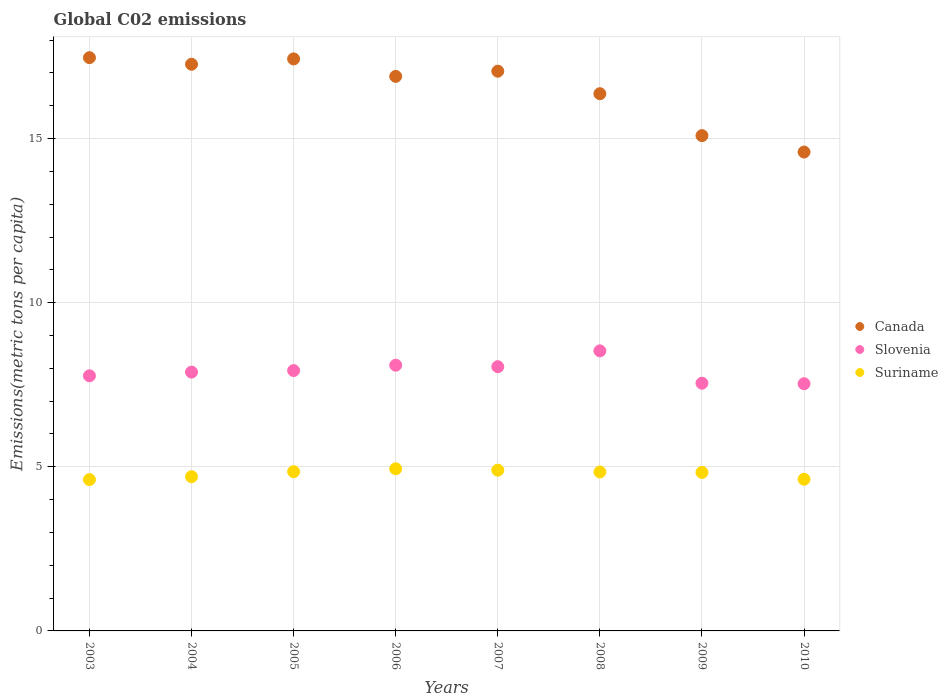Is the number of dotlines equal to the number of legend labels?
Your response must be concise. Yes. What is the amount of CO2 emitted in in Slovenia in 2003?
Your answer should be compact. 7.77. Across all years, what is the maximum amount of CO2 emitted in in Canada?
Give a very brief answer. 17.46. Across all years, what is the minimum amount of CO2 emitted in in Slovenia?
Provide a short and direct response. 7.53. What is the total amount of CO2 emitted in in Canada in the graph?
Ensure brevity in your answer.  132.14. What is the difference between the amount of CO2 emitted in in Suriname in 2004 and that in 2007?
Your answer should be very brief. -0.2. What is the difference between the amount of CO2 emitted in in Suriname in 2004 and the amount of CO2 emitted in in Canada in 2008?
Offer a very short reply. -11.67. What is the average amount of CO2 emitted in in Slovenia per year?
Your answer should be compact. 7.92. In the year 2004, what is the difference between the amount of CO2 emitted in in Suriname and amount of CO2 emitted in in Canada?
Your response must be concise. -12.56. What is the ratio of the amount of CO2 emitted in in Canada in 2005 to that in 2006?
Provide a succinct answer. 1.03. Is the difference between the amount of CO2 emitted in in Suriname in 2005 and 2007 greater than the difference between the amount of CO2 emitted in in Canada in 2005 and 2007?
Ensure brevity in your answer.  No. What is the difference between the highest and the second highest amount of CO2 emitted in in Canada?
Provide a succinct answer. 0.04. What is the difference between the highest and the lowest amount of CO2 emitted in in Slovenia?
Provide a succinct answer. 1. Does the amount of CO2 emitted in in Canada monotonically increase over the years?
Your answer should be compact. No. How many dotlines are there?
Provide a succinct answer. 3. What is the difference between two consecutive major ticks on the Y-axis?
Provide a short and direct response. 5. Are the values on the major ticks of Y-axis written in scientific E-notation?
Ensure brevity in your answer.  No. Does the graph contain grids?
Give a very brief answer. Yes. How are the legend labels stacked?
Offer a terse response. Vertical. What is the title of the graph?
Your answer should be compact. Global C02 emissions. What is the label or title of the X-axis?
Make the answer very short. Years. What is the label or title of the Y-axis?
Your answer should be very brief. Emissions(metric tons per capita). What is the Emissions(metric tons per capita) in Canada in 2003?
Your answer should be very brief. 17.46. What is the Emissions(metric tons per capita) of Slovenia in 2003?
Your response must be concise. 7.77. What is the Emissions(metric tons per capita) in Suriname in 2003?
Make the answer very short. 4.61. What is the Emissions(metric tons per capita) in Canada in 2004?
Give a very brief answer. 17.26. What is the Emissions(metric tons per capita) in Slovenia in 2004?
Your answer should be very brief. 7.88. What is the Emissions(metric tons per capita) of Suriname in 2004?
Give a very brief answer. 4.7. What is the Emissions(metric tons per capita) of Canada in 2005?
Give a very brief answer. 17.43. What is the Emissions(metric tons per capita) in Slovenia in 2005?
Offer a terse response. 7.93. What is the Emissions(metric tons per capita) of Suriname in 2005?
Ensure brevity in your answer.  4.85. What is the Emissions(metric tons per capita) of Canada in 2006?
Offer a very short reply. 16.89. What is the Emissions(metric tons per capita) of Slovenia in 2006?
Make the answer very short. 8.09. What is the Emissions(metric tons per capita) in Suriname in 2006?
Offer a terse response. 4.94. What is the Emissions(metric tons per capita) of Canada in 2007?
Your response must be concise. 17.05. What is the Emissions(metric tons per capita) in Slovenia in 2007?
Your answer should be very brief. 8.05. What is the Emissions(metric tons per capita) in Suriname in 2007?
Provide a succinct answer. 4.9. What is the Emissions(metric tons per capita) of Canada in 2008?
Give a very brief answer. 16.37. What is the Emissions(metric tons per capita) of Slovenia in 2008?
Provide a short and direct response. 8.53. What is the Emissions(metric tons per capita) in Suriname in 2008?
Ensure brevity in your answer.  4.84. What is the Emissions(metric tons per capita) in Canada in 2009?
Provide a short and direct response. 15.09. What is the Emissions(metric tons per capita) of Slovenia in 2009?
Give a very brief answer. 7.55. What is the Emissions(metric tons per capita) in Suriname in 2009?
Make the answer very short. 4.83. What is the Emissions(metric tons per capita) in Canada in 2010?
Keep it short and to the point. 14.59. What is the Emissions(metric tons per capita) of Slovenia in 2010?
Provide a succinct answer. 7.53. What is the Emissions(metric tons per capita) in Suriname in 2010?
Keep it short and to the point. 4.62. Across all years, what is the maximum Emissions(metric tons per capita) of Canada?
Offer a terse response. 17.46. Across all years, what is the maximum Emissions(metric tons per capita) in Slovenia?
Give a very brief answer. 8.53. Across all years, what is the maximum Emissions(metric tons per capita) of Suriname?
Your answer should be very brief. 4.94. Across all years, what is the minimum Emissions(metric tons per capita) in Canada?
Provide a succinct answer. 14.59. Across all years, what is the minimum Emissions(metric tons per capita) in Slovenia?
Keep it short and to the point. 7.53. Across all years, what is the minimum Emissions(metric tons per capita) in Suriname?
Give a very brief answer. 4.61. What is the total Emissions(metric tons per capita) of Canada in the graph?
Your answer should be very brief. 132.14. What is the total Emissions(metric tons per capita) in Slovenia in the graph?
Your answer should be very brief. 63.34. What is the total Emissions(metric tons per capita) in Suriname in the graph?
Your answer should be compact. 38.29. What is the difference between the Emissions(metric tons per capita) of Canada in 2003 and that in 2004?
Your answer should be very brief. 0.2. What is the difference between the Emissions(metric tons per capita) of Slovenia in 2003 and that in 2004?
Keep it short and to the point. -0.11. What is the difference between the Emissions(metric tons per capita) of Suriname in 2003 and that in 2004?
Your answer should be very brief. -0.09. What is the difference between the Emissions(metric tons per capita) of Canada in 2003 and that in 2005?
Provide a succinct answer. 0.04. What is the difference between the Emissions(metric tons per capita) in Slovenia in 2003 and that in 2005?
Ensure brevity in your answer.  -0.16. What is the difference between the Emissions(metric tons per capita) of Suriname in 2003 and that in 2005?
Provide a short and direct response. -0.24. What is the difference between the Emissions(metric tons per capita) in Canada in 2003 and that in 2006?
Keep it short and to the point. 0.57. What is the difference between the Emissions(metric tons per capita) of Slovenia in 2003 and that in 2006?
Offer a very short reply. -0.32. What is the difference between the Emissions(metric tons per capita) of Suriname in 2003 and that in 2006?
Provide a short and direct response. -0.33. What is the difference between the Emissions(metric tons per capita) of Canada in 2003 and that in 2007?
Your answer should be compact. 0.41. What is the difference between the Emissions(metric tons per capita) of Slovenia in 2003 and that in 2007?
Offer a terse response. -0.28. What is the difference between the Emissions(metric tons per capita) of Suriname in 2003 and that in 2007?
Offer a terse response. -0.29. What is the difference between the Emissions(metric tons per capita) in Canada in 2003 and that in 2008?
Provide a short and direct response. 1.1. What is the difference between the Emissions(metric tons per capita) of Slovenia in 2003 and that in 2008?
Your response must be concise. -0.76. What is the difference between the Emissions(metric tons per capita) in Suriname in 2003 and that in 2008?
Offer a very short reply. -0.23. What is the difference between the Emissions(metric tons per capita) in Canada in 2003 and that in 2009?
Your response must be concise. 2.37. What is the difference between the Emissions(metric tons per capita) of Slovenia in 2003 and that in 2009?
Ensure brevity in your answer.  0.23. What is the difference between the Emissions(metric tons per capita) of Suriname in 2003 and that in 2009?
Keep it short and to the point. -0.22. What is the difference between the Emissions(metric tons per capita) of Canada in 2003 and that in 2010?
Keep it short and to the point. 2.87. What is the difference between the Emissions(metric tons per capita) of Slovenia in 2003 and that in 2010?
Your response must be concise. 0.24. What is the difference between the Emissions(metric tons per capita) in Suriname in 2003 and that in 2010?
Ensure brevity in your answer.  -0.01. What is the difference between the Emissions(metric tons per capita) in Canada in 2004 and that in 2005?
Your answer should be compact. -0.16. What is the difference between the Emissions(metric tons per capita) in Slovenia in 2004 and that in 2005?
Provide a short and direct response. -0.05. What is the difference between the Emissions(metric tons per capita) of Suriname in 2004 and that in 2005?
Your answer should be compact. -0.15. What is the difference between the Emissions(metric tons per capita) of Canada in 2004 and that in 2006?
Give a very brief answer. 0.37. What is the difference between the Emissions(metric tons per capita) of Slovenia in 2004 and that in 2006?
Offer a terse response. -0.21. What is the difference between the Emissions(metric tons per capita) in Suriname in 2004 and that in 2006?
Your response must be concise. -0.24. What is the difference between the Emissions(metric tons per capita) of Canada in 2004 and that in 2007?
Ensure brevity in your answer.  0.21. What is the difference between the Emissions(metric tons per capita) in Slovenia in 2004 and that in 2007?
Keep it short and to the point. -0.16. What is the difference between the Emissions(metric tons per capita) in Suriname in 2004 and that in 2007?
Your response must be concise. -0.2. What is the difference between the Emissions(metric tons per capita) of Canada in 2004 and that in 2008?
Your answer should be very brief. 0.9. What is the difference between the Emissions(metric tons per capita) in Slovenia in 2004 and that in 2008?
Your answer should be compact. -0.65. What is the difference between the Emissions(metric tons per capita) of Suriname in 2004 and that in 2008?
Your answer should be compact. -0.14. What is the difference between the Emissions(metric tons per capita) in Canada in 2004 and that in 2009?
Make the answer very short. 2.17. What is the difference between the Emissions(metric tons per capita) of Slovenia in 2004 and that in 2009?
Ensure brevity in your answer.  0.34. What is the difference between the Emissions(metric tons per capita) in Suriname in 2004 and that in 2009?
Offer a very short reply. -0.13. What is the difference between the Emissions(metric tons per capita) of Canada in 2004 and that in 2010?
Provide a succinct answer. 2.67. What is the difference between the Emissions(metric tons per capita) in Slovenia in 2004 and that in 2010?
Ensure brevity in your answer.  0.35. What is the difference between the Emissions(metric tons per capita) in Suriname in 2004 and that in 2010?
Provide a succinct answer. 0.08. What is the difference between the Emissions(metric tons per capita) in Canada in 2005 and that in 2006?
Keep it short and to the point. 0.53. What is the difference between the Emissions(metric tons per capita) of Slovenia in 2005 and that in 2006?
Make the answer very short. -0.16. What is the difference between the Emissions(metric tons per capita) of Suriname in 2005 and that in 2006?
Your answer should be compact. -0.09. What is the difference between the Emissions(metric tons per capita) of Canada in 2005 and that in 2007?
Make the answer very short. 0.37. What is the difference between the Emissions(metric tons per capita) of Slovenia in 2005 and that in 2007?
Offer a very short reply. -0.12. What is the difference between the Emissions(metric tons per capita) in Suriname in 2005 and that in 2007?
Keep it short and to the point. -0.04. What is the difference between the Emissions(metric tons per capita) in Canada in 2005 and that in 2008?
Keep it short and to the point. 1.06. What is the difference between the Emissions(metric tons per capita) in Slovenia in 2005 and that in 2008?
Your response must be concise. -0.6. What is the difference between the Emissions(metric tons per capita) in Suriname in 2005 and that in 2008?
Provide a succinct answer. 0.01. What is the difference between the Emissions(metric tons per capita) of Canada in 2005 and that in 2009?
Provide a short and direct response. 2.34. What is the difference between the Emissions(metric tons per capita) in Slovenia in 2005 and that in 2009?
Your answer should be compact. 0.38. What is the difference between the Emissions(metric tons per capita) of Suriname in 2005 and that in 2009?
Make the answer very short. 0.02. What is the difference between the Emissions(metric tons per capita) in Canada in 2005 and that in 2010?
Offer a terse response. 2.84. What is the difference between the Emissions(metric tons per capita) in Slovenia in 2005 and that in 2010?
Keep it short and to the point. 0.4. What is the difference between the Emissions(metric tons per capita) in Suriname in 2005 and that in 2010?
Provide a short and direct response. 0.23. What is the difference between the Emissions(metric tons per capita) of Canada in 2006 and that in 2007?
Offer a terse response. -0.16. What is the difference between the Emissions(metric tons per capita) of Slovenia in 2006 and that in 2007?
Your answer should be compact. 0.05. What is the difference between the Emissions(metric tons per capita) of Suriname in 2006 and that in 2007?
Your answer should be very brief. 0.04. What is the difference between the Emissions(metric tons per capita) of Canada in 2006 and that in 2008?
Give a very brief answer. 0.53. What is the difference between the Emissions(metric tons per capita) of Slovenia in 2006 and that in 2008?
Keep it short and to the point. -0.44. What is the difference between the Emissions(metric tons per capita) in Suriname in 2006 and that in 2008?
Your answer should be compact. 0.1. What is the difference between the Emissions(metric tons per capita) in Canada in 2006 and that in 2009?
Keep it short and to the point. 1.8. What is the difference between the Emissions(metric tons per capita) of Slovenia in 2006 and that in 2009?
Your answer should be very brief. 0.55. What is the difference between the Emissions(metric tons per capita) in Suriname in 2006 and that in 2009?
Your response must be concise. 0.11. What is the difference between the Emissions(metric tons per capita) of Canada in 2006 and that in 2010?
Offer a very short reply. 2.3. What is the difference between the Emissions(metric tons per capita) in Slovenia in 2006 and that in 2010?
Provide a short and direct response. 0.56. What is the difference between the Emissions(metric tons per capita) of Suriname in 2006 and that in 2010?
Offer a very short reply. 0.32. What is the difference between the Emissions(metric tons per capita) of Canada in 2007 and that in 2008?
Your answer should be compact. 0.69. What is the difference between the Emissions(metric tons per capita) of Slovenia in 2007 and that in 2008?
Offer a very short reply. -0.48. What is the difference between the Emissions(metric tons per capita) in Suriname in 2007 and that in 2008?
Offer a very short reply. 0.06. What is the difference between the Emissions(metric tons per capita) in Canada in 2007 and that in 2009?
Keep it short and to the point. 1.96. What is the difference between the Emissions(metric tons per capita) in Slovenia in 2007 and that in 2009?
Ensure brevity in your answer.  0.5. What is the difference between the Emissions(metric tons per capita) in Suriname in 2007 and that in 2009?
Give a very brief answer. 0.07. What is the difference between the Emissions(metric tons per capita) of Canada in 2007 and that in 2010?
Give a very brief answer. 2.46. What is the difference between the Emissions(metric tons per capita) of Slovenia in 2007 and that in 2010?
Your answer should be very brief. 0.52. What is the difference between the Emissions(metric tons per capita) of Suriname in 2007 and that in 2010?
Make the answer very short. 0.28. What is the difference between the Emissions(metric tons per capita) of Canada in 2008 and that in 2009?
Give a very brief answer. 1.28. What is the difference between the Emissions(metric tons per capita) in Slovenia in 2008 and that in 2009?
Keep it short and to the point. 0.98. What is the difference between the Emissions(metric tons per capita) in Suriname in 2008 and that in 2009?
Your answer should be compact. 0.01. What is the difference between the Emissions(metric tons per capita) of Canada in 2008 and that in 2010?
Offer a terse response. 1.78. What is the difference between the Emissions(metric tons per capita) of Suriname in 2008 and that in 2010?
Keep it short and to the point. 0.22. What is the difference between the Emissions(metric tons per capita) of Slovenia in 2009 and that in 2010?
Keep it short and to the point. 0.02. What is the difference between the Emissions(metric tons per capita) in Suriname in 2009 and that in 2010?
Keep it short and to the point. 0.21. What is the difference between the Emissions(metric tons per capita) in Canada in 2003 and the Emissions(metric tons per capita) in Slovenia in 2004?
Your response must be concise. 9.58. What is the difference between the Emissions(metric tons per capita) of Canada in 2003 and the Emissions(metric tons per capita) of Suriname in 2004?
Provide a short and direct response. 12.77. What is the difference between the Emissions(metric tons per capita) of Slovenia in 2003 and the Emissions(metric tons per capita) of Suriname in 2004?
Give a very brief answer. 3.07. What is the difference between the Emissions(metric tons per capita) in Canada in 2003 and the Emissions(metric tons per capita) in Slovenia in 2005?
Keep it short and to the point. 9.53. What is the difference between the Emissions(metric tons per capita) of Canada in 2003 and the Emissions(metric tons per capita) of Suriname in 2005?
Your response must be concise. 12.61. What is the difference between the Emissions(metric tons per capita) of Slovenia in 2003 and the Emissions(metric tons per capita) of Suriname in 2005?
Make the answer very short. 2.92. What is the difference between the Emissions(metric tons per capita) of Canada in 2003 and the Emissions(metric tons per capita) of Slovenia in 2006?
Make the answer very short. 9.37. What is the difference between the Emissions(metric tons per capita) of Canada in 2003 and the Emissions(metric tons per capita) of Suriname in 2006?
Provide a succinct answer. 12.52. What is the difference between the Emissions(metric tons per capita) in Slovenia in 2003 and the Emissions(metric tons per capita) in Suriname in 2006?
Make the answer very short. 2.83. What is the difference between the Emissions(metric tons per capita) of Canada in 2003 and the Emissions(metric tons per capita) of Slovenia in 2007?
Make the answer very short. 9.41. What is the difference between the Emissions(metric tons per capita) of Canada in 2003 and the Emissions(metric tons per capita) of Suriname in 2007?
Provide a short and direct response. 12.57. What is the difference between the Emissions(metric tons per capita) in Slovenia in 2003 and the Emissions(metric tons per capita) in Suriname in 2007?
Offer a terse response. 2.88. What is the difference between the Emissions(metric tons per capita) of Canada in 2003 and the Emissions(metric tons per capita) of Slovenia in 2008?
Give a very brief answer. 8.93. What is the difference between the Emissions(metric tons per capita) of Canada in 2003 and the Emissions(metric tons per capita) of Suriname in 2008?
Ensure brevity in your answer.  12.62. What is the difference between the Emissions(metric tons per capita) in Slovenia in 2003 and the Emissions(metric tons per capita) in Suriname in 2008?
Give a very brief answer. 2.93. What is the difference between the Emissions(metric tons per capita) in Canada in 2003 and the Emissions(metric tons per capita) in Slovenia in 2009?
Make the answer very short. 9.92. What is the difference between the Emissions(metric tons per capita) in Canada in 2003 and the Emissions(metric tons per capita) in Suriname in 2009?
Keep it short and to the point. 12.63. What is the difference between the Emissions(metric tons per capita) in Slovenia in 2003 and the Emissions(metric tons per capita) in Suriname in 2009?
Offer a terse response. 2.94. What is the difference between the Emissions(metric tons per capita) of Canada in 2003 and the Emissions(metric tons per capita) of Slovenia in 2010?
Give a very brief answer. 9.93. What is the difference between the Emissions(metric tons per capita) in Canada in 2003 and the Emissions(metric tons per capita) in Suriname in 2010?
Provide a short and direct response. 12.84. What is the difference between the Emissions(metric tons per capita) of Slovenia in 2003 and the Emissions(metric tons per capita) of Suriname in 2010?
Your response must be concise. 3.15. What is the difference between the Emissions(metric tons per capita) in Canada in 2004 and the Emissions(metric tons per capita) in Slovenia in 2005?
Ensure brevity in your answer.  9.33. What is the difference between the Emissions(metric tons per capita) in Canada in 2004 and the Emissions(metric tons per capita) in Suriname in 2005?
Provide a short and direct response. 12.41. What is the difference between the Emissions(metric tons per capita) of Slovenia in 2004 and the Emissions(metric tons per capita) of Suriname in 2005?
Offer a terse response. 3.03. What is the difference between the Emissions(metric tons per capita) of Canada in 2004 and the Emissions(metric tons per capita) of Slovenia in 2006?
Keep it short and to the point. 9.17. What is the difference between the Emissions(metric tons per capita) in Canada in 2004 and the Emissions(metric tons per capita) in Suriname in 2006?
Make the answer very short. 12.32. What is the difference between the Emissions(metric tons per capita) in Slovenia in 2004 and the Emissions(metric tons per capita) in Suriname in 2006?
Provide a short and direct response. 2.95. What is the difference between the Emissions(metric tons per capita) in Canada in 2004 and the Emissions(metric tons per capita) in Slovenia in 2007?
Offer a very short reply. 9.21. What is the difference between the Emissions(metric tons per capita) in Canada in 2004 and the Emissions(metric tons per capita) in Suriname in 2007?
Offer a very short reply. 12.37. What is the difference between the Emissions(metric tons per capita) of Slovenia in 2004 and the Emissions(metric tons per capita) of Suriname in 2007?
Give a very brief answer. 2.99. What is the difference between the Emissions(metric tons per capita) in Canada in 2004 and the Emissions(metric tons per capita) in Slovenia in 2008?
Your answer should be compact. 8.73. What is the difference between the Emissions(metric tons per capita) of Canada in 2004 and the Emissions(metric tons per capita) of Suriname in 2008?
Ensure brevity in your answer.  12.42. What is the difference between the Emissions(metric tons per capita) of Slovenia in 2004 and the Emissions(metric tons per capita) of Suriname in 2008?
Your response must be concise. 3.04. What is the difference between the Emissions(metric tons per capita) of Canada in 2004 and the Emissions(metric tons per capita) of Slovenia in 2009?
Offer a terse response. 9.72. What is the difference between the Emissions(metric tons per capita) of Canada in 2004 and the Emissions(metric tons per capita) of Suriname in 2009?
Provide a short and direct response. 12.43. What is the difference between the Emissions(metric tons per capita) of Slovenia in 2004 and the Emissions(metric tons per capita) of Suriname in 2009?
Make the answer very short. 3.06. What is the difference between the Emissions(metric tons per capita) in Canada in 2004 and the Emissions(metric tons per capita) in Slovenia in 2010?
Provide a short and direct response. 9.73. What is the difference between the Emissions(metric tons per capita) in Canada in 2004 and the Emissions(metric tons per capita) in Suriname in 2010?
Give a very brief answer. 12.64. What is the difference between the Emissions(metric tons per capita) in Slovenia in 2004 and the Emissions(metric tons per capita) in Suriname in 2010?
Offer a terse response. 3.26. What is the difference between the Emissions(metric tons per capita) of Canada in 2005 and the Emissions(metric tons per capita) of Slovenia in 2006?
Your answer should be compact. 9.33. What is the difference between the Emissions(metric tons per capita) of Canada in 2005 and the Emissions(metric tons per capita) of Suriname in 2006?
Your answer should be very brief. 12.49. What is the difference between the Emissions(metric tons per capita) in Slovenia in 2005 and the Emissions(metric tons per capita) in Suriname in 2006?
Provide a succinct answer. 2.99. What is the difference between the Emissions(metric tons per capita) of Canada in 2005 and the Emissions(metric tons per capita) of Slovenia in 2007?
Your response must be concise. 9.38. What is the difference between the Emissions(metric tons per capita) of Canada in 2005 and the Emissions(metric tons per capita) of Suriname in 2007?
Your response must be concise. 12.53. What is the difference between the Emissions(metric tons per capita) in Slovenia in 2005 and the Emissions(metric tons per capita) in Suriname in 2007?
Your response must be concise. 3.03. What is the difference between the Emissions(metric tons per capita) in Canada in 2005 and the Emissions(metric tons per capita) in Slovenia in 2008?
Offer a terse response. 8.89. What is the difference between the Emissions(metric tons per capita) of Canada in 2005 and the Emissions(metric tons per capita) of Suriname in 2008?
Ensure brevity in your answer.  12.58. What is the difference between the Emissions(metric tons per capita) of Slovenia in 2005 and the Emissions(metric tons per capita) of Suriname in 2008?
Your answer should be very brief. 3.09. What is the difference between the Emissions(metric tons per capita) of Canada in 2005 and the Emissions(metric tons per capita) of Slovenia in 2009?
Make the answer very short. 9.88. What is the difference between the Emissions(metric tons per capita) of Canada in 2005 and the Emissions(metric tons per capita) of Suriname in 2009?
Offer a terse response. 12.6. What is the difference between the Emissions(metric tons per capita) in Slovenia in 2005 and the Emissions(metric tons per capita) in Suriname in 2009?
Make the answer very short. 3.1. What is the difference between the Emissions(metric tons per capita) in Canada in 2005 and the Emissions(metric tons per capita) in Slovenia in 2010?
Provide a short and direct response. 9.9. What is the difference between the Emissions(metric tons per capita) in Canada in 2005 and the Emissions(metric tons per capita) in Suriname in 2010?
Provide a short and direct response. 12.8. What is the difference between the Emissions(metric tons per capita) of Slovenia in 2005 and the Emissions(metric tons per capita) of Suriname in 2010?
Offer a very short reply. 3.31. What is the difference between the Emissions(metric tons per capita) of Canada in 2006 and the Emissions(metric tons per capita) of Slovenia in 2007?
Give a very brief answer. 8.84. What is the difference between the Emissions(metric tons per capita) in Canada in 2006 and the Emissions(metric tons per capita) in Suriname in 2007?
Keep it short and to the point. 12. What is the difference between the Emissions(metric tons per capita) in Slovenia in 2006 and the Emissions(metric tons per capita) in Suriname in 2007?
Your response must be concise. 3.2. What is the difference between the Emissions(metric tons per capita) in Canada in 2006 and the Emissions(metric tons per capita) in Slovenia in 2008?
Provide a succinct answer. 8.36. What is the difference between the Emissions(metric tons per capita) in Canada in 2006 and the Emissions(metric tons per capita) in Suriname in 2008?
Your response must be concise. 12.05. What is the difference between the Emissions(metric tons per capita) in Slovenia in 2006 and the Emissions(metric tons per capita) in Suriname in 2008?
Give a very brief answer. 3.25. What is the difference between the Emissions(metric tons per capita) of Canada in 2006 and the Emissions(metric tons per capita) of Slovenia in 2009?
Your response must be concise. 9.35. What is the difference between the Emissions(metric tons per capita) of Canada in 2006 and the Emissions(metric tons per capita) of Suriname in 2009?
Your answer should be compact. 12.06. What is the difference between the Emissions(metric tons per capita) in Slovenia in 2006 and the Emissions(metric tons per capita) in Suriname in 2009?
Your answer should be compact. 3.27. What is the difference between the Emissions(metric tons per capita) in Canada in 2006 and the Emissions(metric tons per capita) in Slovenia in 2010?
Give a very brief answer. 9.36. What is the difference between the Emissions(metric tons per capita) of Canada in 2006 and the Emissions(metric tons per capita) of Suriname in 2010?
Keep it short and to the point. 12.27. What is the difference between the Emissions(metric tons per capita) of Slovenia in 2006 and the Emissions(metric tons per capita) of Suriname in 2010?
Provide a succinct answer. 3.47. What is the difference between the Emissions(metric tons per capita) of Canada in 2007 and the Emissions(metric tons per capita) of Slovenia in 2008?
Give a very brief answer. 8.52. What is the difference between the Emissions(metric tons per capita) in Canada in 2007 and the Emissions(metric tons per capita) in Suriname in 2008?
Your answer should be compact. 12.21. What is the difference between the Emissions(metric tons per capita) of Slovenia in 2007 and the Emissions(metric tons per capita) of Suriname in 2008?
Give a very brief answer. 3.21. What is the difference between the Emissions(metric tons per capita) of Canada in 2007 and the Emissions(metric tons per capita) of Slovenia in 2009?
Offer a terse response. 9.5. What is the difference between the Emissions(metric tons per capita) in Canada in 2007 and the Emissions(metric tons per capita) in Suriname in 2009?
Keep it short and to the point. 12.22. What is the difference between the Emissions(metric tons per capita) of Slovenia in 2007 and the Emissions(metric tons per capita) of Suriname in 2009?
Your response must be concise. 3.22. What is the difference between the Emissions(metric tons per capita) of Canada in 2007 and the Emissions(metric tons per capita) of Slovenia in 2010?
Your answer should be very brief. 9.52. What is the difference between the Emissions(metric tons per capita) in Canada in 2007 and the Emissions(metric tons per capita) in Suriname in 2010?
Give a very brief answer. 12.43. What is the difference between the Emissions(metric tons per capita) of Slovenia in 2007 and the Emissions(metric tons per capita) of Suriname in 2010?
Your answer should be very brief. 3.43. What is the difference between the Emissions(metric tons per capita) in Canada in 2008 and the Emissions(metric tons per capita) in Slovenia in 2009?
Ensure brevity in your answer.  8.82. What is the difference between the Emissions(metric tons per capita) in Canada in 2008 and the Emissions(metric tons per capita) in Suriname in 2009?
Offer a very short reply. 11.54. What is the difference between the Emissions(metric tons per capita) of Slovenia in 2008 and the Emissions(metric tons per capita) of Suriname in 2009?
Your answer should be very brief. 3.7. What is the difference between the Emissions(metric tons per capita) in Canada in 2008 and the Emissions(metric tons per capita) in Slovenia in 2010?
Ensure brevity in your answer.  8.84. What is the difference between the Emissions(metric tons per capita) in Canada in 2008 and the Emissions(metric tons per capita) in Suriname in 2010?
Make the answer very short. 11.74. What is the difference between the Emissions(metric tons per capita) in Slovenia in 2008 and the Emissions(metric tons per capita) in Suriname in 2010?
Offer a very short reply. 3.91. What is the difference between the Emissions(metric tons per capita) in Canada in 2009 and the Emissions(metric tons per capita) in Slovenia in 2010?
Offer a very short reply. 7.56. What is the difference between the Emissions(metric tons per capita) of Canada in 2009 and the Emissions(metric tons per capita) of Suriname in 2010?
Your response must be concise. 10.47. What is the difference between the Emissions(metric tons per capita) of Slovenia in 2009 and the Emissions(metric tons per capita) of Suriname in 2010?
Your answer should be very brief. 2.93. What is the average Emissions(metric tons per capita) of Canada per year?
Keep it short and to the point. 16.52. What is the average Emissions(metric tons per capita) in Slovenia per year?
Provide a short and direct response. 7.92. What is the average Emissions(metric tons per capita) in Suriname per year?
Keep it short and to the point. 4.79. In the year 2003, what is the difference between the Emissions(metric tons per capita) of Canada and Emissions(metric tons per capita) of Slovenia?
Make the answer very short. 9.69. In the year 2003, what is the difference between the Emissions(metric tons per capita) of Canada and Emissions(metric tons per capita) of Suriname?
Give a very brief answer. 12.85. In the year 2003, what is the difference between the Emissions(metric tons per capita) of Slovenia and Emissions(metric tons per capita) of Suriname?
Offer a very short reply. 3.16. In the year 2004, what is the difference between the Emissions(metric tons per capita) of Canada and Emissions(metric tons per capita) of Slovenia?
Ensure brevity in your answer.  9.38. In the year 2004, what is the difference between the Emissions(metric tons per capita) of Canada and Emissions(metric tons per capita) of Suriname?
Give a very brief answer. 12.56. In the year 2004, what is the difference between the Emissions(metric tons per capita) in Slovenia and Emissions(metric tons per capita) in Suriname?
Provide a short and direct response. 3.19. In the year 2005, what is the difference between the Emissions(metric tons per capita) in Canada and Emissions(metric tons per capita) in Slovenia?
Provide a succinct answer. 9.49. In the year 2005, what is the difference between the Emissions(metric tons per capita) in Canada and Emissions(metric tons per capita) in Suriname?
Offer a terse response. 12.57. In the year 2005, what is the difference between the Emissions(metric tons per capita) in Slovenia and Emissions(metric tons per capita) in Suriname?
Your response must be concise. 3.08. In the year 2006, what is the difference between the Emissions(metric tons per capita) in Canada and Emissions(metric tons per capita) in Slovenia?
Ensure brevity in your answer.  8.8. In the year 2006, what is the difference between the Emissions(metric tons per capita) of Canada and Emissions(metric tons per capita) of Suriname?
Make the answer very short. 11.95. In the year 2006, what is the difference between the Emissions(metric tons per capita) in Slovenia and Emissions(metric tons per capita) in Suriname?
Provide a short and direct response. 3.16. In the year 2007, what is the difference between the Emissions(metric tons per capita) in Canada and Emissions(metric tons per capita) in Slovenia?
Provide a succinct answer. 9. In the year 2007, what is the difference between the Emissions(metric tons per capita) in Canada and Emissions(metric tons per capita) in Suriname?
Your answer should be compact. 12.15. In the year 2007, what is the difference between the Emissions(metric tons per capita) in Slovenia and Emissions(metric tons per capita) in Suriname?
Provide a short and direct response. 3.15. In the year 2008, what is the difference between the Emissions(metric tons per capita) in Canada and Emissions(metric tons per capita) in Slovenia?
Offer a very short reply. 7.83. In the year 2008, what is the difference between the Emissions(metric tons per capita) in Canada and Emissions(metric tons per capita) in Suriname?
Provide a succinct answer. 11.52. In the year 2008, what is the difference between the Emissions(metric tons per capita) of Slovenia and Emissions(metric tons per capita) of Suriname?
Provide a succinct answer. 3.69. In the year 2009, what is the difference between the Emissions(metric tons per capita) of Canada and Emissions(metric tons per capita) of Slovenia?
Give a very brief answer. 7.54. In the year 2009, what is the difference between the Emissions(metric tons per capita) in Canada and Emissions(metric tons per capita) in Suriname?
Offer a terse response. 10.26. In the year 2009, what is the difference between the Emissions(metric tons per capita) in Slovenia and Emissions(metric tons per capita) in Suriname?
Give a very brief answer. 2.72. In the year 2010, what is the difference between the Emissions(metric tons per capita) of Canada and Emissions(metric tons per capita) of Slovenia?
Provide a short and direct response. 7.06. In the year 2010, what is the difference between the Emissions(metric tons per capita) in Canada and Emissions(metric tons per capita) in Suriname?
Give a very brief answer. 9.97. In the year 2010, what is the difference between the Emissions(metric tons per capita) in Slovenia and Emissions(metric tons per capita) in Suriname?
Offer a terse response. 2.91. What is the ratio of the Emissions(metric tons per capita) of Canada in 2003 to that in 2004?
Provide a short and direct response. 1.01. What is the ratio of the Emissions(metric tons per capita) of Slovenia in 2003 to that in 2004?
Provide a succinct answer. 0.99. What is the ratio of the Emissions(metric tons per capita) in Canada in 2003 to that in 2005?
Provide a short and direct response. 1. What is the ratio of the Emissions(metric tons per capita) in Slovenia in 2003 to that in 2005?
Your response must be concise. 0.98. What is the ratio of the Emissions(metric tons per capita) in Suriname in 2003 to that in 2005?
Your answer should be very brief. 0.95. What is the ratio of the Emissions(metric tons per capita) of Canada in 2003 to that in 2006?
Offer a terse response. 1.03. What is the ratio of the Emissions(metric tons per capita) of Slovenia in 2003 to that in 2006?
Your answer should be compact. 0.96. What is the ratio of the Emissions(metric tons per capita) of Canada in 2003 to that in 2007?
Provide a succinct answer. 1.02. What is the ratio of the Emissions(metric tons per capita) of Slovenia in 2003 to that in 2007?
Keep it short and to the point. 0.97. What is the ratio of the Emissions(metric tons per capita) in Suriname in 2003 to that in 2007?
Offer a very short reply. 0.94. What is the ratio of the Emissions(metric tons per capita) of Canada in 2003 to that in 2008?
Offer a terse response. 1.07. What is the ratio of the Emissions(metric tons per capita) in Slovenia in 2003 to that in 2008?
Offer a very short reply. 0.91. What is the ratio of the Emissions(metric tons per capita) of Suriname in 2003 to that in 2008?
Provide a short and direct response. 0.95. What is the ratio of the Emissions(metric tons per capita) of Canada in 2003 to that in 2009?
Your response must be concise. 1.16. What is the ratio of the Emissions(metric tons per capita) of Slovenia in 2003 to that in 2009?
Your answer should be compact. 1.03. What is the ratio of the Emissions(metric tons per capita) of Suriname in 2003 to that in 2009?
Provide a succinct answer. 0.95. What is the ratio of the Emissions(metric tons per capita) in Canada in 2003 to that in 2010?
Offer a very short reply. 1.2. What is the ratio of the Emissions(metric tons per capita) in Slovenia in 2003 to that in 2010?
Make the answer very short. 1.03. What is the ratio of the Emissions(metric tons per capita) in Suriname in 2003 to that in 2010?
Give a very brief answer. 1. What is the ratio of the Emissions(metric tons per capita) in Canada in 2004 to that in 2005?
Your answer should be very brief. 0.99. What is the ratio of the Emissions(metric tons per capita) in Slovenia in 2004 to that in 2005?
Provide a short and direct response. 0.99. What is the ratio of the Emissions(metric tons per capita) of Suriname in 2004 to that in 2005?
Your answer should be compact. 0.97. What is the ratio of the Emissions(metric tons per capita) of Canada in 2004 to that in 2006?
Offer a terse response. 1.02. What is the ratio of the Emissions(metric tons per capita) of Slovenia in 2004 to that in 2006?
Offer a terse response. 0.97. What is the ratio of the Emissions(metric tons per capita) in Suriname in 2004 to that in 2006?
Keep it short and to the point. 0.95. What is the ratio of the Emissions(metric tons per capita) in Canada in 2004 to that in 2007?
Your answer should be very brief. 1.01. What is the ratio of the Emissions(metric tons per capita) of Slovenia in 2004 to that in 2007?
Give a very brief answer. 0.98. What is the ratio of the Emissions(metric tons per capita) of Suriname in 2004 to that in 2007?
Give a very brief answer. 0.96. What is the ratio of the Emissions(metric tons per capita) of Canada in 2004 to that in 2008?
Your answer should be very brief. 1.05. What is the ratio of the Emissions(metric tons per capita) in Slovenia in 2004 to that in 2008?
Provide a short and direct response. 0.92. What is the ratio of the Emissions(metric tons per capita) of Suriname in 2004 to that in 2008?
Ensure brevity in your answer.  0.97. What is the ratio of the Emissions(metric tons per capita) in Canada in 2004 to that in 2009?
Your answer should be very brief. 1.14. What is the ratio of the Emissions(metric tons per capita) of Slovenia in 2004 to that in 2009?
Keep it short and to the point. 1.04. What is the ratio of the Emissions(metric tons per capita) in Suriname in 2004 to that in 2009?
Provide a succinct answer. 0.97. What is the ratio of the Emissions(metric tons per capita) in Canada in 2004 to that in 2010?
Your response must be concise. 1.18. What is the ratio of the Emissions(metric tons per capita) in Slovenia in 2004 to that in 2010?
Give a very brief answer. 1.05. What is the ratio of the Emissions(metric tons per capita) of Suriname in 2004 to that in 2010?
Offer a terse response. 1.02. What is the ratio of the Emissions(metric tons per capita) of Canada in 2005 to that in 2006?
Give a very brief answer. 1.03. What is the ratio of the Emissions(metric tons per capita) in Slovenia in 2005 to that in 2006?
Give a very brief answer. 0.98. What is the ratio of the Emissions(metric tons per capita) in Suriname in 2005 to that in 2006?
Your answer should be very brief. 0.98. What is the ratio of the Emissions(metric tons per capita) of Canada in 2005 to that in 2007?
Provide a succinct answer. 1.02. What is the ratio of the Emissions(metric tons per capita) of Slovenia in 2005 to that in 2007?
Give a very brief answer. 0.99. What is the ratio of the Emissions(metric tons per capita) of Suriname in 2005 to that in 2007?
Offer a terse response. 0.99. What is the ratio of the Emissions(metric tons per capita) of Canada in 2005 to that in 2008?
Ensure brevity in your answer.  1.06. What is the ratio of the Emissions(metric tons per capita) in Slovenia in 2005 to that in 2008?
Offer a very short reply. 0.93. What is the ratio of the Emissions(metric tons per capita) in Suriname in 2005 to that in 2008?
Ensure brevity in your answer.  1. What is the ratio of the Emissions(metric tons per capita) in Canada in 2005 to that in 2009?
Your response must be concise. 1.15. What is the ratio of the Emissions(metric tons per capita) of Slovenia in 2005 to that in 2009?
Offer a very short reply. 1.05. What is the ratio of the Emissions(metric tons per capita) in Suriname in 2005 to that in 2009?
Your answer should be compact. 1. What is the ratio of the Emissions(metric tons per capita) of Canada in 2005 to that in 2010?
Give a very brief answer. 1.19. What is the ratio of the Emissions(metric tons per capita) of Slovenia in 2005 to that in 2010?
Offer a terse response. 1.05. What is the ratio of the Emissions(metric tons per capita) in Suriname in 2005 to that in 2010?
Your answer should be compact. 1.05. What is the ratio of the Emissions(metric tons per capita) of Canada in 2006 to that in 2007?
Your answer should be compact. 0.99. What is the ratio of the Emissions(metric tons per capita) of Slovenia in 2006 to that in 2007?
Your answer should be compact. 1.01. What is the ratio of the Emissions(metric tons per capita) in Suriname in 2006 to that in 2007?
Make the answer very short. 1.01. What is the ratio of the Emissions(metric tons per capita) of Canada in 2006 to that in 2008?
Keep it short and to the point. 1.03. What is the ratio of the Emissions(metric tons per capita) in Slovenia in 2006 to that in 2008?
Give a very brief answer. 0.95. What is the ratio of the Emissions(metric tons per capita) of Suriname in 2006 to that in 2008?
Ensure brevity in your answer.  1.02. What is the ratio of the Emissions(metric tons per capita) in Canada in 2006 to that in 2009?
Offer a terse response. 1.12. What is the ratio of the Emissions(metric tons per capita) in Slovenia in 2006 to that in 2009?
Offer a terse response. 1.07. What is the ratio of the Emissions(metric tons per capita) in Suriname in 2006 to that in 2009?
Provide a succinct answer. 1.02. What is the ratio of the Emissions(metric tons per capita) of Canada in 2006 to that in 2010?
Provide a succinct answer. 1.16. What is the ratio of the Emissions(metric tons per capita) in Slovenia in 2006 to that in 2010?
Keep it short and to the point. 1.07. What is the ratio of the Emissions(metric tons per capita) in Suriname in 2006 to that in 2010?
Offer a very short reply. 1.07. What is the ratio of the Emissions(metric tons per capita) of Canada in 2007 to that in 2008?
Give a very brief answer. 1.04. What is the ratio of the Emissions(metric tons per capita) of Slovenia in 2007 to that in 2008?
Offer a very short reply. 0.94. What is the ratio of the Emissions(metric tons per capita) in Suriname in 2007 to that in 2008?
Your response must be concise. 1.01. What is the ratio of the Emissions(metric tons per capita) of Canada in 2007 to that in 2009?
Provide a short and direct response. 1.13. What is the ratio of the Emissions(metric tons per capita) of Slovenia in 2007 to that in 2009?
Keep it short and to the point. 1.07. What is the ratio of the Emissions(metric tons per capita) of Suriname in 2007 to that in 2009?
Your answer should be compact. 1.01. What is the ratio of the Emissions(metric tons per capita) of Canada in 2007 to that in 2010?
Your answer should be very brief. 1.17. What is the ratio of the Emissions(metric tons per capita) of Slovenia in 2007 to that in 2010?
Your answer should be compact. 1.07. What is the ratio of the Emissions(metric tons per capita) of Suriname in 2007 to that in 2010?
Your answer should be very brief. 1.06. What is the ratio of the Emissions(metric tons per capita) in Canada in 2008 to that in 2009?
Provide a short and direct response. 1.08. What is the ratio of the Emissions(metric tons per capita) of Slovenia in 2008 to that in 2009?
Give a very brief answer. 1.13. What is the ratio of the Emissions(metric tons per capita) in Suriname in 2008 to that in 2009?
Ensure brevity in your answer.  1. What is the ratio of the Emissions(metric tons per capita) of Canada in 2008 to that in 2010?
Your response must be concise. 1.12. What is the ratio of the Emissions(metric tons per capita) in Slovenia in 2008 to that in 2010?
Ensure brevity in your answer.  1.13. What is the ratio of the Emissions(metric tons per capita) of Suriname in 2008 to that in 2010?
Provide a succinct answer. 1.05. What is the ratio of the Emissions(metric tons per capita) of Canada in 2009 to that in 2010?
Your answer should be very brief. 1.03. What is the ratio of the Emissions(metric tons per capita) in Slovenia in 2009 to that in 2010?
Give a very brief answer. 1. What is the ratio of the Emissions(metric tons per capita) in Suriname in 2009 to that in 2010?
Offer a very short reply. 1.04. What is the difference between the highest and the second highest Emissions(metric tons per capita) of Canada?
Ensure brevity in your answer.  0.04. What is the difference between the highest and the second highest Emissions(metric tons per capita) of Slovenia?
Provide a succinct answer. 0.44. What is the difference between the highest and the second highest Emissions(metric tons per capita) in Suriname?
Your response must be concise. 0.04. What is the difference between the highest and the lowest Emissions(metric tons per capita) in Canada?
Ensure brevity in your answer.  2.87. What is the difference between the highest and the lowest Emissions(metric tons per capita) in Suriname?
Offer a very short reply. 0.33. 